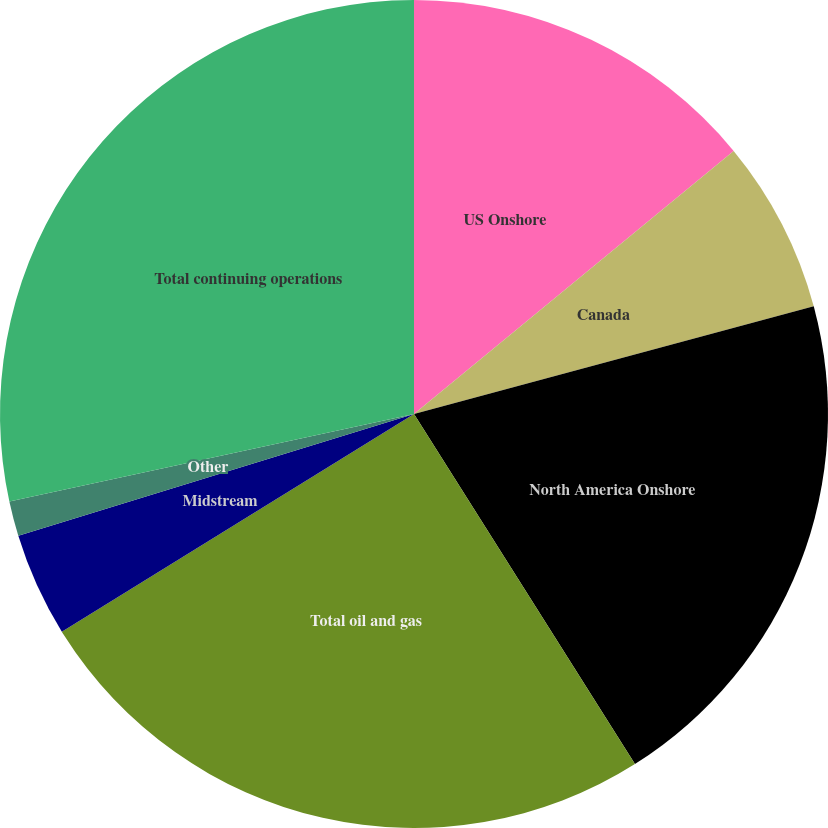Convert chart to OTSL. <chart><loc_0><loc_0><loc_500><loc_500><pie_chart><fcel>US Onshore<fcel>Canada<fcel>North America Onshore<fcel>Total oil and gas<fcel>Midstream<fcel>Other<fcel>Total continuing operations<nl><fcel>14.04%<fcel>6.77%<fcel>20.23%<fcel>25.15%<fcel>4.06%<fcel>1.36%<fcel>28.39%<nl></chart> 